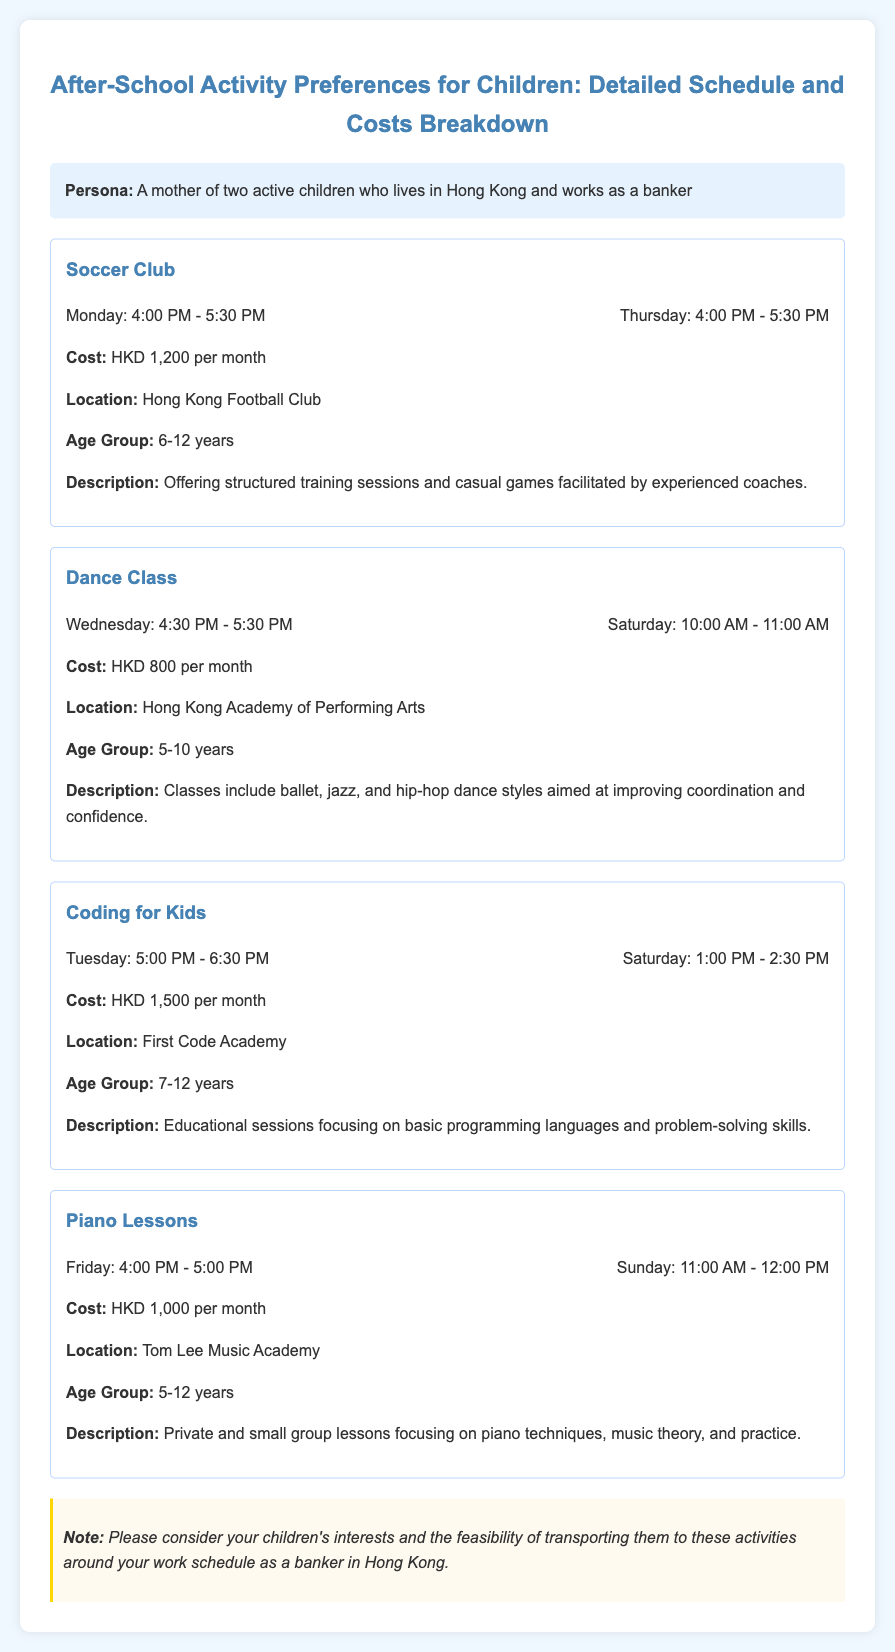what is the cost of the Soccer Club? The cost of the Soccer Club is stated in the document as HKD 1,200 per month.
Answer: HKD 1,200 what day and time does the Dance Class take place? The Dance Class is scheduled for Wednesday from 4:30 PM to 5:30 PM and Saturday from 10:00 AM to 11:00 AM.
Answer: Wednesday and Saturday what is the age group for Coding for Kids? The document specifies the age group for Coding for Kids as 7-12 years.
Answer: 7-12 years how many children are the after-school activities designed for? The document does not specify the exact number of children; it describes activities for different age groups.
Answer: Not specified which activity occurs on Friday? The activity described in the document that takes place on Friday is Piano Lessons.
Answer: Piano Lessons what location is listed for the Coding for Kids activity? The location for Coding for Kids, as mentioned in the document, is First Code Academy.
Answer: First Code Academy what is the total monthly cost for all four activities? The total monthly cost is calculated by adding the costs of all activities: 1200 + 800 + 1500 + 1000 = 3500 HKD.
Answer: HKD 3,500 how does the document suggest considering scheduling? The document notes that one should consider their children's interests and the feasibility of transporting them to the activities around the parent's work schedule.
Answer: Interests and feasibility of transport what are the two types of classes included in Dance Class? The Dance Class includes ballet, jazz, and hip-hop dance styles, which are specified in the document.
Answer: ballet, jazz, hip-hop 